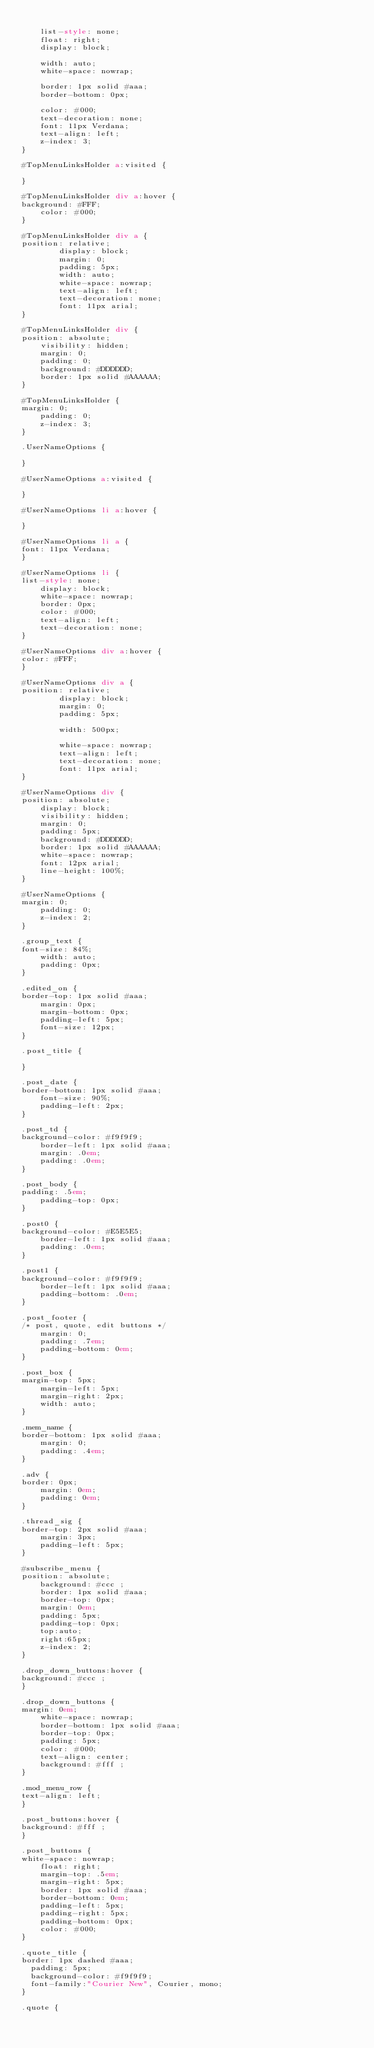Convert code to text. <code><loc_0><loc_0><loc_500><loc_500><_HTML_>    
    list-style: none;
    float: right;
    display: block;
    
    width: auto;
    white-space: nowrap;
    
    border: 1px solid #aaa;
    border-bottom: 0px;
    
    color: #000;
    text-decoration: none;
    font: 11px Verdana;
    text-align: left;
    z-index: 3;
}

#TopMenuLinksHolder a:visited {

}

#TopMenuLinksHolder div a:hover {
background: #FFF;
    color: #000;
}

#TopMenuLinksHolder div a {
position: relative;
        display: block;
        margin: 0;
        padding: 5px;
        width: auto;
        white-space: nowrap;
        text-align: left;
        text-decoration: none;
        font: 11px arial;
}

#TopMenuLinksHolder div {
position: absolute;
    visibility: hidden;
    margin: 0;
    padding: 0;
    background: #DDDDDD;
    border: 1px solid #AAAAAA;
}

#TopMenuLinksHolder {
margin: 0;
    padding: 0;
    z-index: 3;
}

.UserNameOptions {

}

#UserNameOptions a:visited {

}

#UserNameOptions li a:hover {

}

#UserNameOptions li a {
font: 11px Verdana;
}

#UserNameOptions li {
list-style: none;
    display: block;
    white-space: nowrap;
    border: 0px;
    color: #000;
    text-align: left;
    text-decoration: none;
}

#UserNameOptions div a:hover {
color: #FFF;
}

#UserNameOptions div a {
position: relative;
        display: block;
        margin: 0;
        padding: 5px;
        
        width: 500px;
        
        white-space: nowrap; 
        text-align: left;
        text-decoration: none;
        font: 11px arial;
}

#UserNameOptions div {
position: absolute;
    display: block;
    visibility: hidden;
    margin: 0;
    padding: 5px;
    background: #DDDDDD;
    border: 1px solid #AAAAAA;
    white-space: nowrap; 
    font: 12px arial;
    line-height: 100%;
}

#UserNameOptions {
margin: 0;
    padding: 0;
    z-index: 2;
}

.group_text {
font-size: 84%;
    width: auto;
    padding: 0px;
}

.edited_on {
border-top: 1px solid #aaa;
    margin: 0px;
    margin-bottom: 0px;
    padding-left: 5px;
    font-size: 12px;
}

.post_title {

}

.post_date {
border-bottom: 1px solid #aaa;
    font-size: 90%;
    padding-left: 2px;
}

.post_td {
background-color: #f9f9f9;
    border-left: 1px solid #aaa;
    margin: .0em;
    padding: .0em;
}

.post_body {
padding: .5em;
    padding-top: 0px;
}

.post0 {
background-color: #E5E5E5;
    border-left: 1px solid #aaa;
    padding: .0em;
}

.post1 {
background-color: #f9f9f9;
    border-left: 1px solid #aaa;
    padding-bottom: .0em;
}

.post_footer {
/* post, quote, edit buttons */
    margin: 0;
    padding: .7em;
    padding-bottom: 0em;
}

.post_box {
margin-top: 5px;
    margin-left: 5px;
    margin-right: 2px;
    width: auto;
}

.mem_name {
border-bottom: 1px solid #aaa;
    margin: 0;
    padding: .4em;
}

.adv {
border: 0px;
    margin: 0em;
    padding: 0em;
}

.thread_sig {
border-top: 2px solid #aaa;
    margin: 3px;
    padding-left: 5px;
}

#subscribe_menu {
position: absolute;
    background: #ccc ;
    border: 1px solid #aaa;
    border-top: 0px;
    margin: 0em;
    padding: 5px;
    padding-top: 0px;
    top:auto;
    right:65px;
    z-index: 2;
}

.drop_down_buttons:hover {
background: #ccc ;
}

.drop_down_buttons {
margin: 0em;
    white-space: nowrap;
    border-bottom: 1px solid #aaa;
    border-top: 0px;
    padding: 5px;
    color: #000;
    text-align: center;
    background: #fff ;
}

.mod_menu_row {
text-align: left;
}

.post_buttons:hover {
background: #fff ;
}

.post_buttons {
white-space: nowrap;
    float: right;
    margin-top: .5em;
    margin-right: 5px;
    border: 1px solid #aaa;
    border-bottom: 0em;
    padding-left: 5px;
    padding-right: 5px;
    padding-bottom: 0px;
    color: #000;
}

.quote_title {
border: 1px dashed #aaa;
	padding: 5px;
	background-color: #f9f9f9;
	font-family:"Courier New", Courier, mono;
}

.quote {</code> 